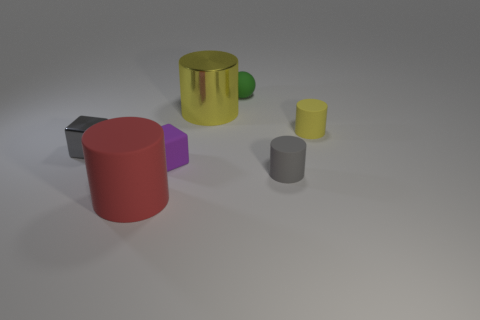Is there any other thing of the same color as the small sphere? Upon inspecting the image, it appears that there is no other object precisely matching the hue of the small sphere. Each object in the scene has a unique color; therefore, the small sphere's shade is distinct. 